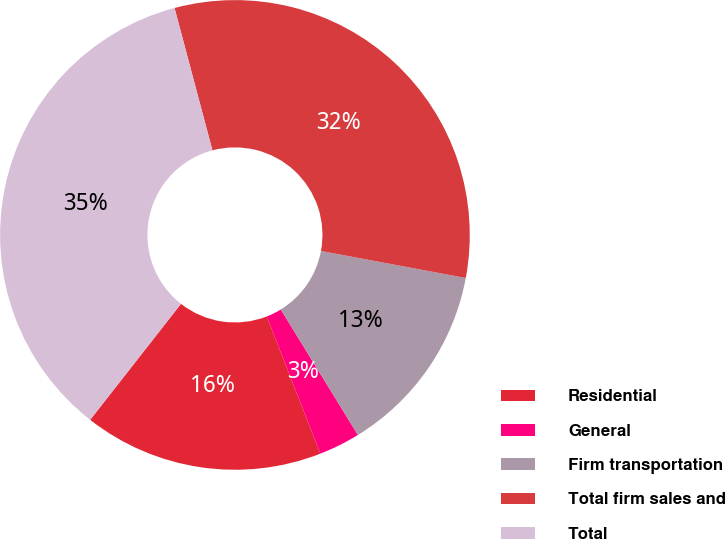<chart> <loc_0><loc_0><loc_500><loc_500><pie_chart><fcel>Residential<fcel>General<fcel>Firm transportation<fcel>Total firm sales and<fcel>Total<nl><fcel>16.5%<fcel>2.85%<fcel>13.29%<fcel>32.08%<fcel>35.29%<nl></chart> 